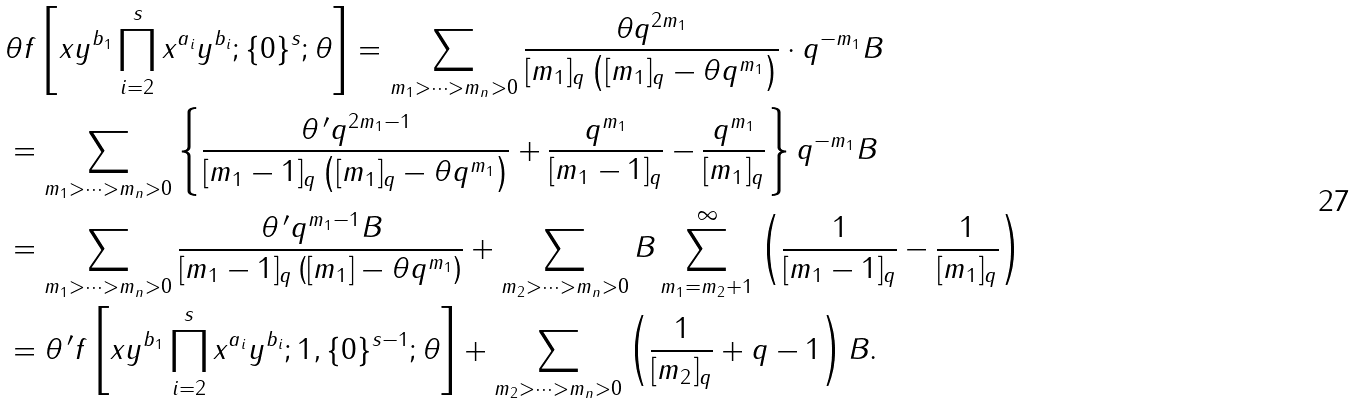<formula> <loc_0><loc_0><loc_500><loc_500>& \theta f \left [ x y ^ { b _ { 1 } } \prod _ { i = 2 } ^ { s } x ^ { a _ { i } } y ^ { b _ { i } } ; \{ 0 \} ^ { s } ; \theta \right ] = \sum _ { m _ { 1 } > \cdots > m _ { n } > 0 } \frac { \theta q ^ { 2 m _ { 1 } } } { [ m _ { 1 } ] _ { q } \left ( [ m _ { 1 } ] _ { q } - \theta q ^ { m _ { 1 } } \right ) } \cdot q ^ { - m _ { 1 } } B \\ & = \sum _ { m _ { 1 } > \cdots > m _ { n } > 0 } \left \{ \frac { \theta \, ^ { \prime } q ^ { 2 m _ { 1 } - 1 } } { [ m _ { 1 } - 1 ] _ { q } \left ( [ m _ { 1 } ] _ { q } - \theta q ^ { m _ { 1 } } \right ) } + \frac { q ^ { m _ { 1 } } } { [ m _ { 1 } - 1 ] _ { q } } - \frac { q ^ { m _ { 1 } } } { [ m _ { 1 } ] _ { q } } \right \} q ^ { - m _ { 1 } } B \\ & = \sum _ { m _ { 1 } > \cdots > m _ { n } > 0 } \frac { \theta \, ^ { \prime } q ^ { m _ { 1 } - 1 } B } { [ m _ { 1 } - 1 ] _ { q } \left ( [ m _ { 1 } ] - \theta q ^ { m _ { 1 } } \right ) } + \sum _ { m _ { 2 } > \cdots > m _ { n } > 0 } B \sum _ { m _ { 1 } = m _ { 2 } + 1 } ^ { \infty } \left ( \frac { 1 } { [ m _ { 1 } - 1 ] _ { q } } - \frac { 1 } { [ m _ { 1 } ] _ { q } } \right ) \\ & = \theta \, ^ { \prime } f \left [ x y ^ { b _ { 1 } } \prod _ { i = 2 } ^ { s } x ^ { a _ { i } } y ^ { b _ { i } } ; 1 , \{ 0 \} ^ { s - 1 } ; \theta \right ] + \sum _ { m _ { 2 } > \cdots > m _ { n } > 0 } \left ( \frac { 1 } { [ m _ { 2 } ] _ { q } } + q - 1 \right ) B .</formula> 